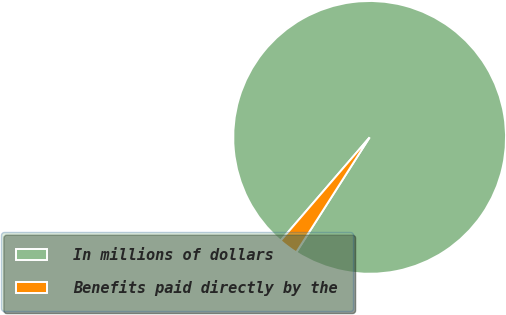<chart> <loc_0><loc_0><loc_500><loc_500><pie_chart><fcel>In millions of dollars<fcel>Benefits paid directly by the<nl><fcel>97.73%<fcel>2.27%<nl></chart> 